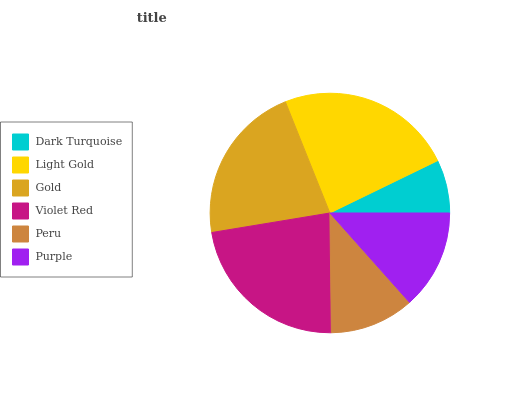Is Dark Turquoise the minimum?
Answer yes or no. Yes. Is Light Gold the maximum?
Answer yes or no. Yes. Is Gold the minimum?
Answer yes or no. No. Is Gold the maximum?
Answer yes or no. No. Is Light Gold greater than Gold?
Answer yes or no. Yes. Is Gold less than Light Gold?
Answer yes or no. Yes. Is Gold greater than Light Gold?
Answer yes or no. No. Is Light Gold less than Gold?
Answer yes or no. No. Is Gold the high median?
Answer yes or no. Yes. Is Purple the low median?
Answer yes or no. Yes. Is Peru the high median?
Answer yes or no. No. Is Light Gold the low median?
Answer yes or no. No. 